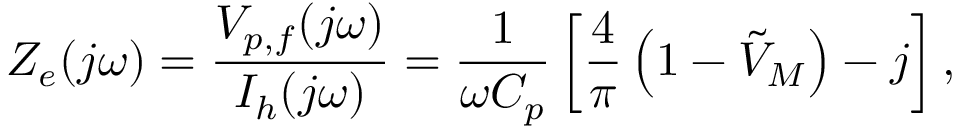<formula> <loc_0><loc_0><loc_500><loc_500>{ Z _ { e } } ( j \omega ) = \frac { { { V _ { p , f } } ( j \omega ) } } { { { I _ { h } } ( j \omega ) } } = \frac { 1 } { { \omega { C _ { p } } } } \left [ \frac { 4 } { \pi } \left ( 1 - \tilde { V } _ { M } \right ) - j \right ] ,</formula> 